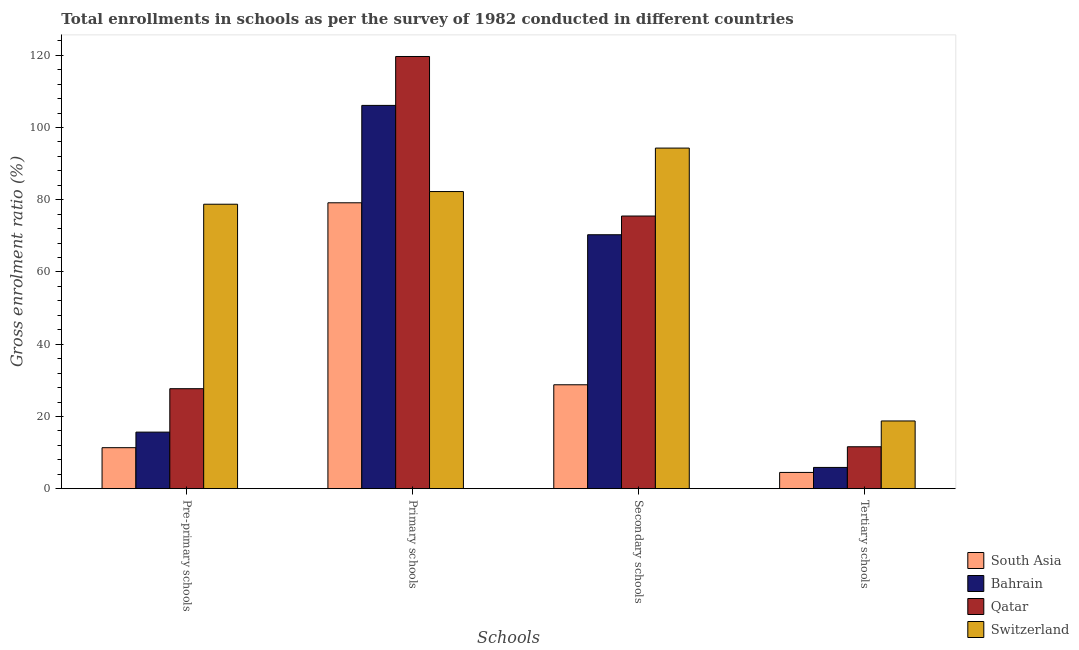How many different coloured bars are there?
Your answer should be compact. 4. Are the number of bars per tick equal to the number of legend labels?
Provide a succinct answer. Yes. How many bars are there on the 3rd tick from the right?
Keep it short and to the point. 4. What is the label of the 4th group of bars from the left?
Your answer should be compact. Tertiary schools. What is the gross enrolment ratio in secondary schools in Switzerland?
Make the answer very short. 94.31. Across all countries, what is the maximum gross enrolment ratio in primary schools?
Provide a succinct answer. 119.67. Across all countries, what is the minimum gross enrolment ratio in primary schools?
Keep it short and to the point. 79.16. In which country was the gross enrolment ratio in tertiary schools maximum?
Provide a succinct answer. Switzerland. What is the total gross enrolment ratio in pre-primary schools in the graph?
Give a very brief answer. 133.46. What is the difference between the gross enrolment ratio in pre-primary schools in South Asia and that in Switzerland?
Your response must be concise. -67.41. What is the difference between the gross enrolment ratio in pre-primary schools in Bahrain and the gross enrolment ratio in tertiary schools in Qatar?
Provide a succinct answer. 4.05. What is the average gross enrolment ratio in primary schools per country?
Your answer should be very brief. 96.81. What is the difference between the gross enrolment ratio in secondary schools and gross enrolment ratio in pre-primary schools in Bahrain?
Your answer should be compact. 54.65. What is the ratio of the gross enrolment ratio in pre-primary schools in Qatar to that in South Asia?
Your answer should be very brief. 2.44. Is the gross enrolment ratio in primary schools in Switzerland less than that in South Asia?
Make the answer very short. No. What is the difference between the highest and the second highest gross enrolment ratio in primary schools?
Offer a terse response. 13.54. What is the difference between the highest and the lowest gross enrolment ratio in primary schools?
Your answer should be very brief. 40.51. What does the 1st bar from the left in Tertiary schools represents?
Your answer should be very brief. South Asia. What does the 1st bar from the right in Tertiary schools represents?
Make the answer very short. Switzerland. How many countries are there in the graph?
Offer a very short reply. 4. What is the difference between two consecutive major ticks on the Y-axis?
Provide a short and direct response. 20. Are the values on the major ticks of Y-axis written in scientific E-notation?
Offer a terse response. No. Does the graph contain grids?
Ensure brevity in your answer.  No. Where does the legend appear in the graph?
Your response must be concise. Bottom right. How many legend labels are there?
Provide a short and direct response. 4. What is the title of the graph?
Offer a very short reply. Total enrollments in schools as per the survey of 1982 conducted in different countries. Does "Portugal" appear as one of the legend labels in the graph?
Keep it short and to the point. No. What is the label or title of the X-axis?
Provide a short and direct response. Schools. What is the Gross enrolment ratio (%) in South Asia in Pre-primary schools?
Give a very brief answer. 11.35. What is the Gross enrolment ratio (%) of Bahrain in Pre-primary schools?
Ensure brevity in your answer.  15.66. What is the Gross enrolment ratio (%) in Qatar in Pre-primary schools?
Provide a short and direct response. 27.69. What is the Gross enrolment ratio (%) in Switzerland in Pre-primary schools?
Ensure brevity in your answer.  78.76. What is the Gross enrolment ratio (%) of South Asia in Primary schools?
Make the answer very short. 79.16. What is the Gross enrolment ratio (%) in Bahrain in Primary schools?
Provide a short and direct response. 106.13. What is the Gross enrolment ratio (%) of Qatar in Primary schools?
Your answer should be very brief. 119.67. What is the Gross enrolment ratio (%) in Switzerland in Primary schools?
Your answer should be compact. 82.27. What is the Gross enrolment ratio (%) in South Asia in Secondary schools?
Offer a terse response. 28.77. What is the Gross enrolment ratio (%) in Bahrain in Secondary schools?
Ensure brevity in your answer.  70.31. What is the Gross enrolment ratio (%) in Qatar in Secondary schools?
Offer a very short reply. 75.5. What is the Gross enrolment ratio (%) of Switzerland in Secondary schools?
Provide a short and direct response. 94.31. What is the Gross enrolment ratio (%) in South Asia in Tertiary schools?
Keep it short and to the point. 4.5. What is the Gross enrolment ratio (%) in Bahrain in Tertiary schools?
Provide a short and direct response. 5.88. What is the Gross enrolment ratio (%) in Qatar in Tertiary schools?
Provide a short and direct response. 11.61. What is the Gross enrolment ratio (%) of Switzerland in Tertiary schools?
Your answer should be compact. 18.75. Across all Schools, what is the maximum Gross enrolment ratio (%) of South Asia?
Offer a terse response. 79.16. Across all Schools, what is the maximum Gross enrolment ratio (%) of Bahrain?
Provide a succinct answer. 106.13. Across all Schools, what is the maximum Gross enrolment ratio (%) in Qatar?
Ensure brevity in your answer.  119.67. Across all Schools, what is the maximum Gross enrolment ratio (%) of Switzerland?
Your answer should be very brief. 94.31. Across all Schools, what is the minimum Gross enrolment ratio (%) of South Asia?
Your answer should be very brief. 4.5. Across all Schools, what is the minimum Gross enrolment ratio (%) of Bahrain?
Your answer should be very brief. 5.88. Across all Schools, what is the minimum Gross enrolment ratio (%) in Qatar?
Your answer should be very brief. 11.61. Across all Schools, what is the minimum Gross enrolment ratio (%) in Switzerland?
Provide a succinct answer. 18.75. What is the total Gross enrolment ratio (%) of South Asia in the graph?
Make the answer very short. 123.78. What is the total Gross enrolment ratio (%) of Bahrain in the graph?
Your answer should be compact. 197.99. What is the total Gross enrolment ratio (%) in Qatar in the graph?
Provide a succinct answer. 234.46. What is the total Gross enrolment ratio (%) of Switzerland in the graph?
Offer a terse response. 274.1. What is the difference between the Gross enrolment ratio (%) in South Asia in Pre-primary schools and that in Primary schools?
Offer a terse response. -67.81. What is the difference between the Gross enrolment ratio (%) in Bahrain in Pre-primary schools and that in Primary schools?
Your response must be concise. -90.47. What is the difference between the Gross enrolment ratio (%) of Qatar in Pre-primary schools and that in Primary schools?
Your response must be concise. -91.99. What is the difference between the Gross enrolment ratio (%) in Switzerland in Pre-primary schools and that in Primary schools?
Your answer should be very brief. -3.51. What is the difference between the Gross enrolment ratio (%) of South Asia in Pre-primary schools and that in Secondary schools?
Offer a terse response. -17.42. What is the difference between the Gross enrolment ratio (%) of Bahrain in Pre-primary schools and that in Secondary schools?
Give a very brief answer. -54.65. What is the difference between the Gross enrolment ratio (%) in Qatar in Pre-primary schools and that in Secondary schools?
Your answer should be compact. -47.81. What is the difference between the Gross enrolment ratio (%) in Switzerland in Pre-primary schools and that in Secondary schools?
Provide a succinct answer. -15.55. What is the difference between the Gross enrolment ratio (%) of South Asia in Pre-primary schools and that in Tertiary schools?
Offer a very short reply. 6.85. What is the difference between the Gross enrolment ratio (%) in Bahrain in Pre-primary schools and that in Tertiary schools?
Your answer should be very brief. 9.78. What is the difference between the Gross enrolment ratio (%) of Qatar in Pre-primary schools and that in Tertiary schools?
Your answer should be compact. 16.08. What is the difference between the Gross enrolment ratio (%) in Switzerland in Pre-primary schools and that in Tertiary schools?
Give a very brief answer. 60.01. What is the difference between the Gross enrolment ratio (%) in South Asia in Primary schools and that in Secondary schools?
Give a very brief answer. 50.39. What is the difference between the Gross enrolment ratio (%) in Bahrain in Primary schools and that in Secondary schools?
Give a very brief answer. 35.81. What is the difference between the Gross enrolment ratio (%) in Qatar in Primary schools and that in Secondary schools?
Provide a short and direct response. 44.18. What is the difference between the Gross enrolment ratio (%) in Switzerland in Primary schools and that in Secondary schools?
Give a very brief answer. -12.04. What is the difference between the Gross enrolment ratio (%) of South Asia in Primary schools and that in Tertiary schools?
Give a very brief answer. 74.66. What is the difference between the Gross enrolment ratio (%) in Bahrain in Primary schools and that in Tertiary schools?
Provide a short and direct response. 100.24. What is the difference between the Gross enrolment ratio (%) of Qatar in Primary schools and that in Tertiary schools?
Provide a short and direct response. 108.07. What is the difference between the Gross enrolment ratio (%) in Switzerland in Primary schools and that in Tertiary schools?
Your answer should be very brief. 63.52. What is the difference between the Gross enrolment ratio (%) in South Asia in Secondary schools and that in Tertiary schools?
Make the answer very short. 24.27. What is the difference between the Gross enrolment ratio (%) in Bahrain in Secondary schools and that in Tertiary schools?
Your answer should be very brief. 64.43. What is the difference between the Gross enrolment ratio (%) of Qatar in Secondary schools and that in Tertiary schools?
Make the answer very short. 63.89. What is the difference between the Gross enrolment ratio (%) in Switzerland in Secondary schools and that in Tertiary schools?
Your answer should be compact. 75.56. What is the difference between the Gross enrolment ratio (%) in South Asia in Pre-primary schools and the Gross enrolment ratio (%) in Bahrain in Primary schools?
Your answer should be very brief. -94.78. What is the difference between the Gross enrolment ratio (%) in South Asia in Pre-primary schools and the Gross enrolment ratio (%) in Qatar in Primary schools?
Offer a very short reply. -108.32. What is the difference between the Gross enrolment ratio (%) of South Asia in Pre-primary schools and the Gross enrolment ratio (%) of Switzerland in Primary schools?
Provide a short and direct response. -70.92. What is the difference between the Gross enrolment ratio (%) of Bahrain in Pre-primary schools and the Gross enrolment ratio (%) of Qatar in Primary schools?
Your answer should be very brief. -104.01. What is the difference between the Gross enrolment ratio (%) in Bahrain in Pre-primary schools and the Gross enrolment ratio (%) in Switzerland in Primary schools?
Your answer should be very brief. -66.61. What is the difference between the Gross enrolment ratio (%) of Qatar in Pre-primary schools and the Gross enrolment ratio (%) of Switzerland in Primary schools?
Your answer should be very brief. -54.59. What is the difference between the Gross enrolment ratio (%) in South Asia in Pre-primary schools and the Gross enrolment ratio (%) in Bahrain in Secondary schools?
Provide a short and direct response. -58.96. What is the difference between the Gross enrolment ratio (%) in South Asia in Pre-primary schools and the Gross enrolment ratio (%) in Qatar in Secondary schools?
Provide a short and direct response. -64.14. What is the difference between the Gross enrolment ratio (%) in South Asia in Pre-primary schools and the Gross enrolment ratio (%) in Switzerland in Secondary schools?
Provide a succinct answer. -82.96. What is the difference between the Gross enrolment ratio (%) in Bahrain in Pre-primary schools and the Gross enrolment ratio (%) in Qatar in Secondary schools?
Give a very brief answer. -59.84. What is the difference between the Gross enrolment ratio (%) of Bahrain in Pre-primary schools and the Gross enrolment ratio (%) of Switzerland in Secondary schools?
Provide a succinct answer. -78.65. What is the difference between the Gross enrolment ratio (%) in Qatar in Pre-primary schools and the Gross enrolment ratio (%) in Switzerland in Secondary schools?
Your response must be concise. -66.62. What is the difference between the Gross enrolment ratio (%) of South Asia in Pre-primary schools and the Gross enrolment ratio (%) of Bahrain in Tertiary schools?
Give a very brief answer. 5.47. What is the difference between the Gross enrolment ratio (%) of South Asia in Pre-primary schools and the Gross enrolment ratio (%) of Qatar in Tertiary schools?
Give a very brief answer. -0.25. What is the difference between the Gross enrolment ratio (%) in South Asia in Pre-primary schools and the Gross enrolment ratio (%) in Switzerland in Tertiary schools?
Your answer should be very brief. -7.4. What is the difference between the Gross enrolment ratio (%) in Bahrain in Pre-primary schools and the Gross enrolment ratio (%) in Qatar in Tertiary schools?
Provide a short and direct response. 4.05. What is the difference between the Gross enrolment ratio (%) of Bahrain in Pre-primary schools and the Gross enrolment ratio (%) of Switzerland in Tertiary schools?
Offer a very short reply. -3.09. What is the difference between the Gross enrolment ratio (%) in Qatar in Pre-primary schools and the Gross enrolment ratio (%) in Switzerland in Tertiary schools?
Your answer should be very brief. 8.94. What is the difference between the Gross enrolment ratio (%) in South Asia in Primary schools and the Gross enrolment ratio (%) in Bahrain in Secondary schools?
Offer a very short reply. 8.85. What is the difference between the Gross enrolment ratio (%) of South Asia in Primary schools and the Gross enrolment ratio (%) of Qatar in Secondary schools?
Provide a short and direct response. 3.66. What is the difference between the Gross enrolment ratio (%) in South Asia in Primary schools and the Gross enrolment ratio (%) in Switzerland in Secondary schools?
Ensure brevity in your answer.  -15.15. What is the difference between the Gross enrolment ratio (%) in Bahrain in Primary schools and the Gross enrolment ratio (%) in Qatar in Secondary schools?
Keep it short and to the point. 30.63. What is the difference between the Gross enrolment ratio (%) in Bahrain in Primary schools and the Gross enrolment ratio (%) in Switzerland in Secondary schools?
Make the answer very short. 11.82. What is the difference between the Gross enrolment ratio (%) in Qatar in Primary schools and the Gross enrolment ratio (%) in Switzerland in Secondary schools?
Your response must be concise. 25.36. What is the difference between the Gross enrolment ratio (%) in South Asia in Primary schools and the Gross enrolment ratio (%) in Bahrain in Tertiary schools?
Make the answer very short. 73.28. What is the difference between the Gross enrolment ratio (%) in South Asia in Primary schools and the Gross enrolment ratio (%) in Qatar in Tertiary schools?
Ensure brevity in your answer.  67.55. What is the difference between the Gross enrolment ratio (%) in South Asia in Primary schools and the Gross enrolment ratio (%) in Switzerland in Tertiary schools?
Provide a succinct answer. 60.41. What is the difference between the Gross enrolment ratio (%) of Bahrain in Primary schools and the Gross enrolment ratio (%) of Qatar in Tertiary schools?
Your answer should be compact. 94.52. What is the difference between the Gross enrolment ratio (%) in Bahrain in Primary schools and the Gross enrolment ratio (%) in Switzerland in Tertiary schools?
Keep it short and to the point. 87.38. What is the difference between the Gross enrolment ratio (%) in Qatar in Primary schools and the Gross enrolment ratio (%) in Switzerland in Tertiary schools?
Give a very brief answer. 100.92. What is the difference between the Gross enrolment ratio (%) in South Asia in Secondary schools and the Gross enrolment ratio (%) in Bahrain in Tertiary schools?
Offer a terse response. 22.89. What is the difference between the Gross enrolment ratio (%) of South Asia in Secondary schools and the Gross enrolment ratio (%) of Qatar in Tertiary schools?
Provide a succinct answer. 17.17. What is the difference between the Gross enrolment ratio (%) of South Asia in Secondary schools and the Gross enrolment ratio (%) of Switzerland in Tertiary schools?
Your response must be concise. 10.02. What is the difference between the Gross enrolment ratio (%) of Bahrain in Secondary schools and the Gross enrolment ratio (%) of Qatar in Tertiary schools?
Keep it short and to the point. 58.71. What is the difference between the Gross enrolment ratio (%) of Bahrain in Secondary schools and the Gross enrolment ratio (%) of Switzerland in Tertiary schools?
Provide a short and direct response. 51.56. What is the difference between the Gross enrolment ratio (%) in Qatar in Secondary schools and the Gross enrolment ratio (%) in Switzerland in Tertiary schools?
Your answer should be very brief. 56.75. What is the average Gross enrolment ratio (%) in South Asia per Schools?
Ensure brevity in your answer.  30.95. What is the average Gross enrolment ratio (%) in Bahrain per Schools?
Keep it short and to the point. 49.5. What is the average Gross enrolment ratio (%) of Qatar per Schools?
Your answer should be compact. 58.62. What is the average Gross enrolment ratio (%) of Switzerland per Schools?
Offer a very short reply. 68.52. What is the difference between the Gross enrolment ratio (%) of South Asia and Gross enrolment ratio (%) of Bahrain in Pre-primary schools?
Offer a terse response. -4.31. What is the difference between the Gross enrolment ratio (%) in South Asia and Gross enrolment ratio (%) in Qatar in Pre-primary schools?
Keep it short and to the point. -16.33. What is the difference between the Gross enrolment ratio (%) of South Asia and Gross enrolment ratio (%) of Switzerland in Pre-primary schools?
Your answer should be very brief. -67.41. What is the difference between the Gross enrolment ratio (%) in Bahrain and Gross enrolment ratio (%) in Qatar in Pre-primary schools?
Your response must be concise. -12.03. What is the difference between the Gross enrolment ratio (%) in Bahrain and Gross enrolment ratio (%) in Switzerland in Pre-primary schools?
Your answer should be very brief. -63.1. What is the difference between the Gross enrolment ratio (%) of Qatar and Gross enrolment ratio (%) of Switzerland in Pre-primary schools?
Make the answer very short. -51.08. What is the difference between the Gross enrolment ratio (%) of South Asia and Gross enrolment ratio (%) of Bahrain in Primary schools?
Ensure brevity in your answer.  -26.97. What is the difference between the Gross enrolment ratio (%) in South Asia and Gross enrolment ratio (%) in Qatar in Primary schools?
Your answer should be very brief. -40.51. What is the difference between the Gross enrolment ratio (%) of South Asia and Gross enrolment ratio (%) of Switzerland in Primary schools?
Offer a terse response. -3.11. What is the difference between the Gross enrolment ratio (%) of Bahrain and Gross enrolment ratio (%) of Qatar in Primary schools?
Your answer should be very brief. -13.54. What is the difference between the Gross enrolment ratio (%) in Bahrain and Gross enrolment ratio (%) in Switzerland in Primary schools?
Your response must be concise. 23.85. What is the difference between the Gross enrolment ratio (%) in Qatar and Gross enrolment ratio (%) in Switzerland in Primary schools?
Keep it short and to the point. 37.4. What is the difference between the Gross enrolment ratio (%) in South Asia and Gross enrolment ratio (%) in Bahrain in Secondary schools?
Offer a very short reply. -41.54. What is the difference between the Gross enrolment ratio (%) of South Asia and Gross enrolment ratio (%) of Qatar in Secondary schools?
Ensure brevity in your answer.  -46.72. What is the difference between the Gross enrolment ratio (%) in South Asia and Gross enrolment ratio (%) in Switzerland in Secondary schools?
Ensure brevity in your answer.  -65.54. What is the difference between the Gross enrolment ratio (%) of Bahrain and Gross enrolment ratio (%) of Qatar in Secondary schools?
Your answer should be very brief. -5.18. What is the difference between the Gross enrolment ratio (%) in Bahrain and Gross enrolment ratio (%) in Switzerland in Secondary schools?
Give a very brief answer. -24. What is the difference between the Gross enrolment ratio (%) of Qatar and Gross enrolment ratio (%) of Switzerland in Secondary schools?
Offer a very short reply. -18.81. What is the difference between the Gross enrolment ratio (%) of South Asia and Gross enrolment ratio (%) of Bahrain in Tertiary schools?
Make the answer very short. -1.38. What is the difference between the Gross enrolment ratio (%) of South Asia and Gross enrolment ratio (%) of Qatar in Tertiary schools?
Give a very brief answer. -7.11. What is the difference between the Gross enrolment ratio (%) of South Asia and Gross enrolment ratio (%) of Switzerland in Tertiary schools?
Ensure brevity in your answer.  -14.25. What is the difference between the Gross enrolment ratio (%) of Bahrain and Gross enrolment ratio (%) of Qatar in Tertiary schools?
Make the answer very short. -5.72. What is the difference between the Gross enrolment ratio (%) of Bahrain and Gross enrolment ratio (%) of Switzerland in Tertiary schools?
Provide a short and direct response. -12.87. What is the difference between the Gross enrolment ratio (%) of Qatar and Gross enrolment ratio (%) of Switzerland in Tertiary schools?
Give a very brief answer. -7.14. What is the ratio of the Gross enrolment ratio (%) of South Asia in Pre-primary schools to that in Primary schools?
Your answer should be compact. 0.14. What is the ratio of the Gross enrolment ratio (%) of Bahrain in Pre-primary schools to that in Primary schools?
Provide a short and direct response. 0.15. What is the ratio of the Gross enrolment ratio (%) in Qatar in Pre-primary schools to that in Primary schools?
Provide a succinct answer. 0.23. What is the ratio of the Gross enrolment ratio (%) of Switzerland in Pre-primary schools to that in Primary schools?
Keep it short and to the point. 0.96. What is the ratio of the Gross enrolment ratio (%) in South Asia in Pre-primary schools to that in Secondary schools?
Make the answer very short. 0.39. What is the ratio of the Gross enrolment ratio (%) in Bahrain in Pre-primary schools to that in Secondary schools?
Give a very brief answer. 0.22. What is the ratio of the Gross enrolment ratio (%) in Qatar in Pre-primary schools to that in Secondary schools?
Give a very brief answer. 0.37. What is the ratio of the Gross enrolment ratio (%) of Switzerland in Pre-primary schools to that in Secondary schools?
Your answer should be very brief. 0.84. What is the ratio of the Gross enrolment ratio (%) in South Asia in Pre-primary schools to that in Tertiary schools?
Provide a short and direct response. 2.52. What is the ratio of the Gross enrolment ratio (%) in Bahrain in Pre-primary schools to that in Tertiary schools?
Make the answer very short. 2.66. What is the ratio of the Gross enrolment ratio (%) in Qatar in Pre-primary schools to that in Tertiary schools?
Provide a short and direct response. 2.39. What is the ratio of the Gross enrolment ratio (%) of Switzerland in Pre-primary schools to that in Tertiary schools?
Ensure brevity in your answer.  4.2. What is the ratio of the Gross enrolment ratio (%) of South Asia in Primary schools to that in Secondary schools?
Offer a terse response. 2.75. What is the ratio of the Gross enrolment ratio (%) in Bahrain in Primary schools to that in Secondary schools?
Keep it short and to the point. 1.51. What is the ratio of the Gross enrolment ratio (%) in Qatar in Primary schools to that in Secondary schools?
Your response must be concise. 1.59. What is the ratio of the Gross enrolment ratio (%) of Switzerland in Primary schools to that in Secondary schools?
Make the answer very short. 0.87. What is the ratio of the Gross enrolment ratio (%) in South Asia in Primary schools to that in Tertiary schools?
Offer a terse response. 17.59. What is the ratio of the Gross enrolment ratio (%) in Bahrain in Primary schools to that in Tertiary schools?
Your answer should be very brief. 18.04. What is the ratio of the Gross enrolment ratio (%) in Qatar in Primary schools to that in Tertiary schools?
Your answer should be very brief. 10.31. What is the ratio of the Gross enrolment ratio (%) in Switzerland in Primary schools to that in Tertiary schools?
Your answer should be compact. 4.39. What is the ratio of the Gross enrolment ratio (%) of South Asia in Secondary schools to that in Tertiary schools?
Make the answer very short. 6.39. What is the ratio of the Gross enrolment ratio (%) in Bahrain in Secondary schools to that in Tertiary schools?
Offer a very short reply. 11.95. What is the ratio of the Gross enrolment ratio (%) in Qatar in Secondary schools to that in Tertiary schools?
Your response must be concise. 6.5. What is the ratio of the Gross enrolment ratio (%) of Switzerland in Secondary schools to that in Tertiary schools?
Your answer should be compact. 5.03. What is the difference between the highest and the second highest Gross enrolment ratio (%) in South Asia?
Keep it short and to the point. 50.39. What is the difference between the highest and the second highest Gross enrolment ratio (%) in Bahrain?
Keep it short and to the point. 35.81. What is the difference between the highest and the second highest Gross enrolment ratio (%) in Qatar?
Give a very brief answer. 44.18. What is the difference between the highest and the second highest Gross enrolment ratio (%) in Switzerland?
Provide a short and direct response. 12.04. What is the difference between the highest and the lowest Gross enrolment ratio (%) in South Asia?
Offer a terse response. 74.66. What is the difference between the highest and the lowest Gross enrolment ratio (%) in Bahrain?
Make the answer very short. 100.24. What is the difference between the highest and the lowest Gross enrolment ratio (%) in Qatar?
Provide a short and direct response. 108.07. What is the difference between the highest and the lowest Gross enrolment ratio (%) in Switzerland?
Keep it short and to the point. 75.56. 